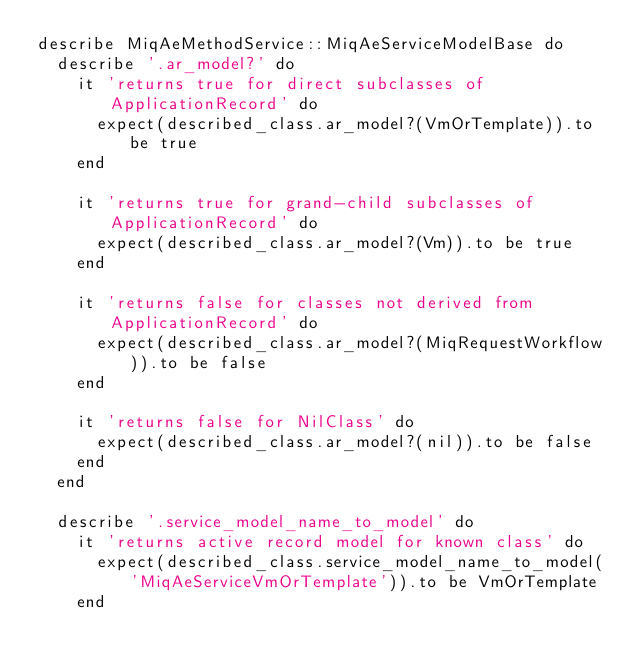<code> <loc_0><loc_0><loc_500><loc_500><_Ruby_>describe MiqAeMethodService::MiqAeServiceModelBase do
  describe '.ar_model?' do
    it 'returns true for direct subclasses of ApplicationRecord' do
      expect(described_class.ar_model?(VmOrTemplate)).to be true
    end

    it 'returns true for grand-child subclasses of ApplicationRecord' do
      expect(described_class.ar_model?(Vm)).to be true
    end

    it 'returns false for classes not derived from ApplicationRecord' do
      expect(described_class.ar_model?(MiqRequestWorkflow)).to be false
    end

    it 'returns false for NilClass' do
      expect(described_class.ar_model?(nil)).to be false
    end
  end

  describe '.service_model_name_to_model' do
    it 'returns active record model for known class' do
      expect(described_class.service_model_name_to_model('MiqAeServiceVmOrTemplate')).to be VmOrTemplate
    end
</code> 